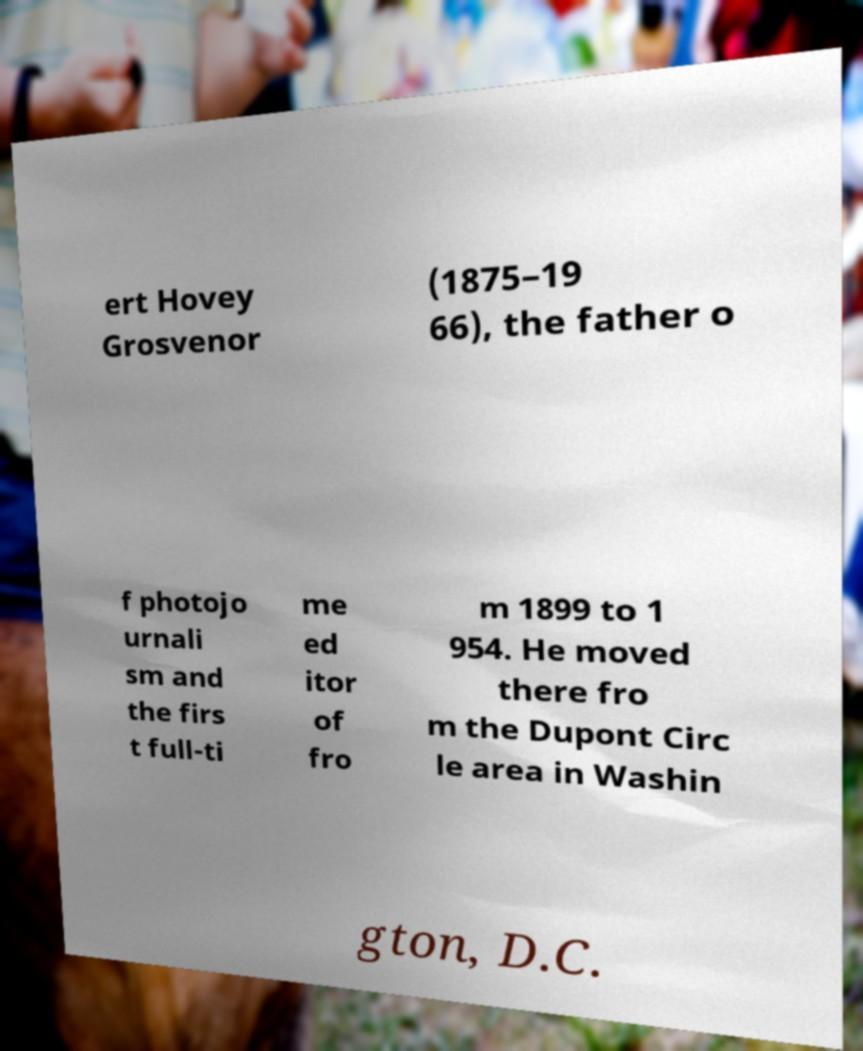What messages or text are displayed in this image? I need them in a readable, typed format. ert Hovey Grosvenor (1875–19 66), the father o f photojo urnali sm and the firs t full-ti me ed itor of fro m 1899 to 1 954. He moved there fro m the Dupont Circ le area in Washin gton, D.C. 